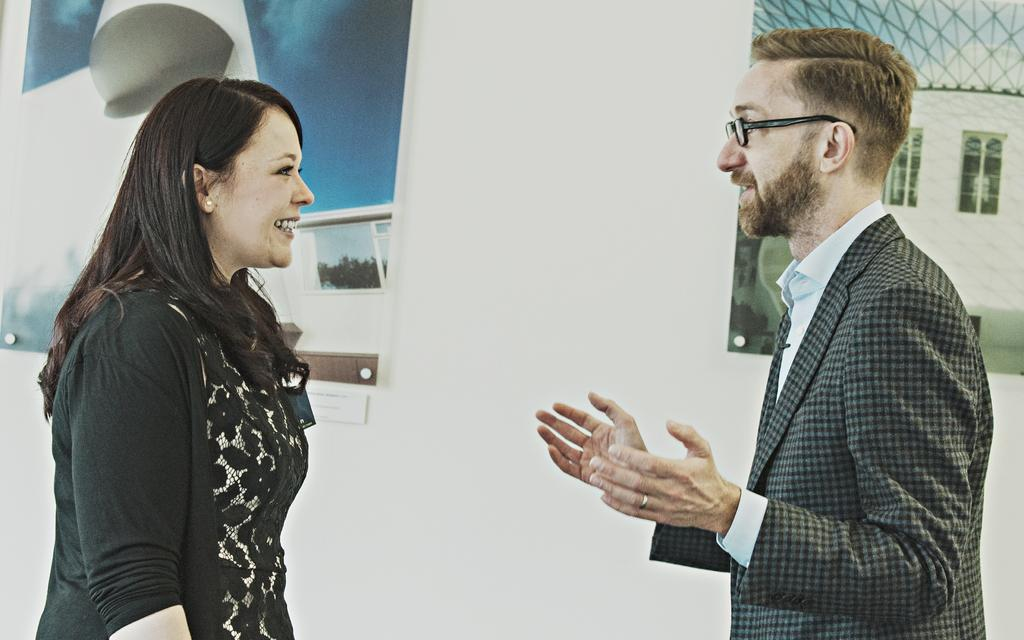Who can be seen on the left side of the image in the foreground? There is a woman in the foreground of the image on the left side. Who can be seen on the right side of the image in the foreground? There is a man in the foreground of the image on the right side. What can be seen on the wall in the background of the image? There are two posters on the wall in the background of the image. What type of celery is the woman holding in the image? There is no celery present in the image; the woman is not holding any vegetables. Can you tell me the age of the woman's grandmother in the image? There is no grandmother present in the image, and therefore no information about her age can be determined. 